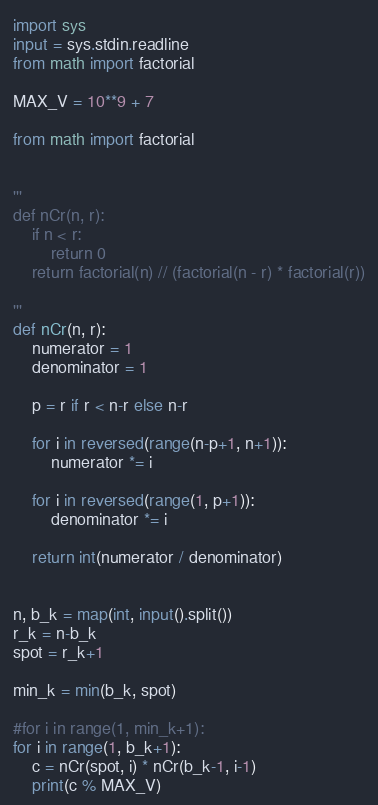Convert code to text. <code><loc_0><loc_0><loc_500><loc_500><_Python_>import sys
input = sys.stdin.readline
from math import factorial

MAX_V = 10**9 + 7

from math import factorial


'''
def nCr(n, r):
    if n < r:
        return 0
    return factorial(n) // (factorial(n - r) * factorial(r))

'''
def nCr(n, r):
    numerator = 1
    denominator = 1

    p = r if r < n-r else n-r

    for i in reversed(range(n-p+1, n+1)):
        numerator *= i

    for i in reversed(range(1, p+1)):
        denominator *= i

    return int(numerator / denominator)


n, b_k = map(int, input().split())
r_k = n-b_k
spot = r_k+1

min_k = min(b_k, spot)

#for i in range(1, min_k+1):
for i in range(1, b_k+1):
    c = nCr(spot, i) * nCr(b_k-1, i-1)
    print(c % MAX_V)</code> 